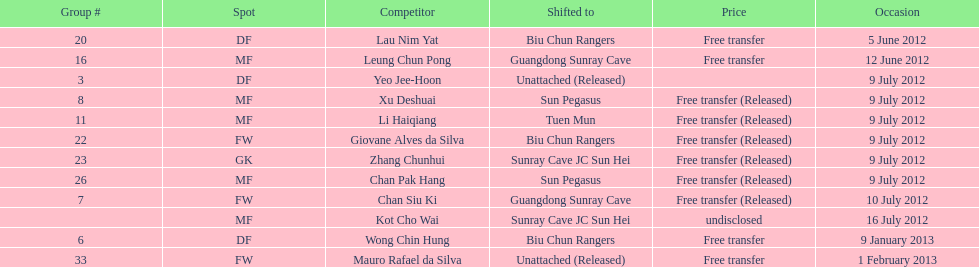Li haiqiang and xu deshuai both played which position? MF. Would you be able to parse every entry in this table? {'header': ['Group #', 'Spot', 'Competitor', 'Shifted to', 'Price', 'Occasion'], 'rows': [['20', 'DF', 'Lau Nim Yat', 'Biu Chun Rangers', 'Free transfer', '5 June 2012'], ['16', 'MF', 'Leung Chun Pong', 'Guangdong Sunray Cave', 'Free transfer', '12 June 2012'], ['3', 'DF', 'Yeo Jee-Hoon', 'Unattached (Released)', '', '9 July 2012'], ['8', 'MF', 'Xu Deshuai', 'Sun Pegasus', 'Free transfer (Released)', '9 July 2012'], ['11', 'MF', 'Li Haiqiang', 'Tuen Mun', 'Free transfer (Released)', '9 July 2012'], ['22', 'FW', 'Giovane Alves da Silva', 'Biu Chun Rangers', 'Free transfer (Released)', '9 July 2012'], ['23', 'GK', 'Zhang Chunhui', 'Sunray Cave JC Sun Hei', 'Free transfer (Released)', '9 July 2012'], ['26', 'MF', 'Chan Pak Hang', 'Sun Pegasus', 'Free transfer (Released)', '9 July 2012'], ['7', 'FW', 'Chan Siu Ki', 'Guangdong Sunray Cave', 'Free transfer (Released)', '10 July 2012'], ['', 'MF', 'Kot Cho Wai', 'Sunray Cave JC Sun Hei', 'undisclosed', '16 July 2012'], ['6', 'DF', 'Wong Chin Hung', 'Biu Chun Rangers', 'Free transfer', '9 January 2013'], ['33', 'FW', 'Mauro Rafael da Silva', 'Unattached (Released)', 'Free transfer', '1 February 2013']]} 